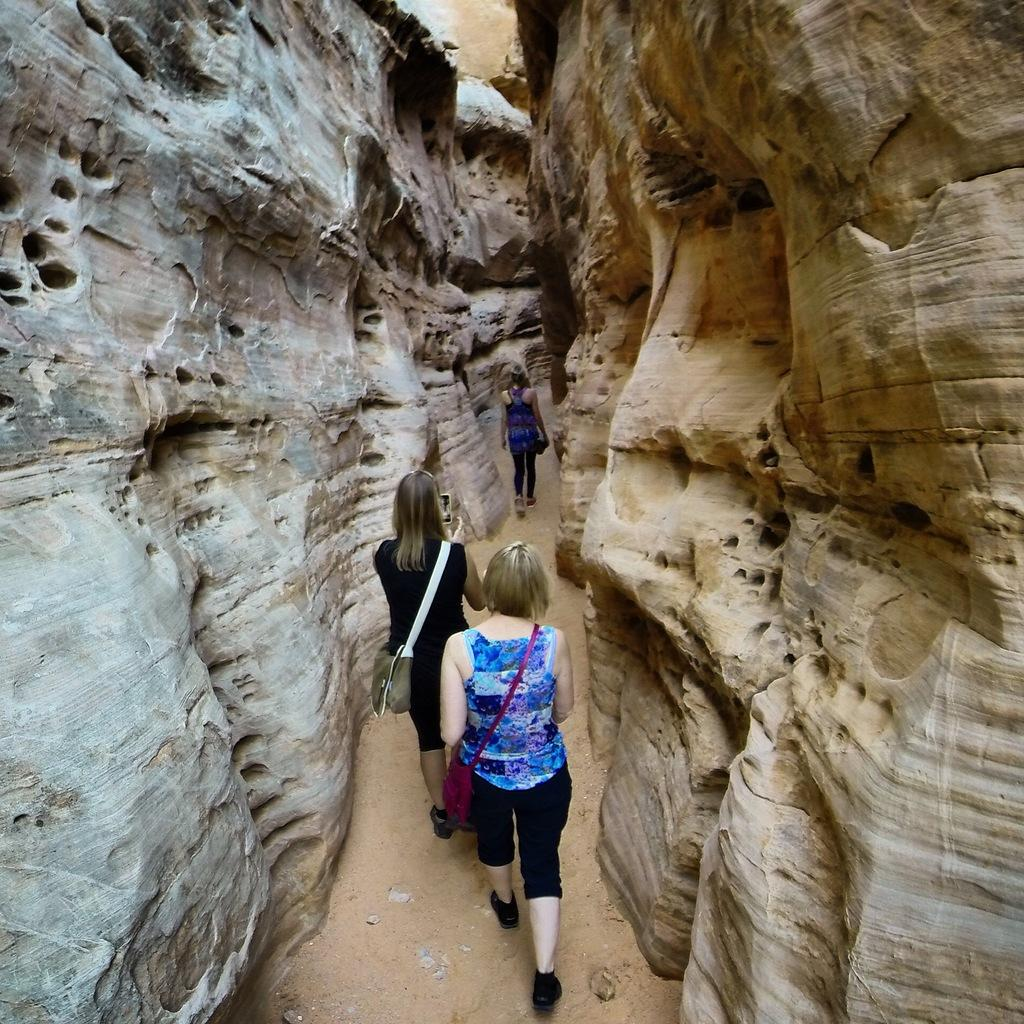How many women are in the image? There are three women in the image. What are the women carrying? The women are carrying bags. What surface are the women walking on? The women are walking on the ground. What can be seen in the background of the image? There are rocks visible in the background of the image. What type of mark can be seen on the rocks in the image? There is no mark visible on the rocks in the image. What song is the group of women singing in the image? There is no indication that the women are singing in the image. 